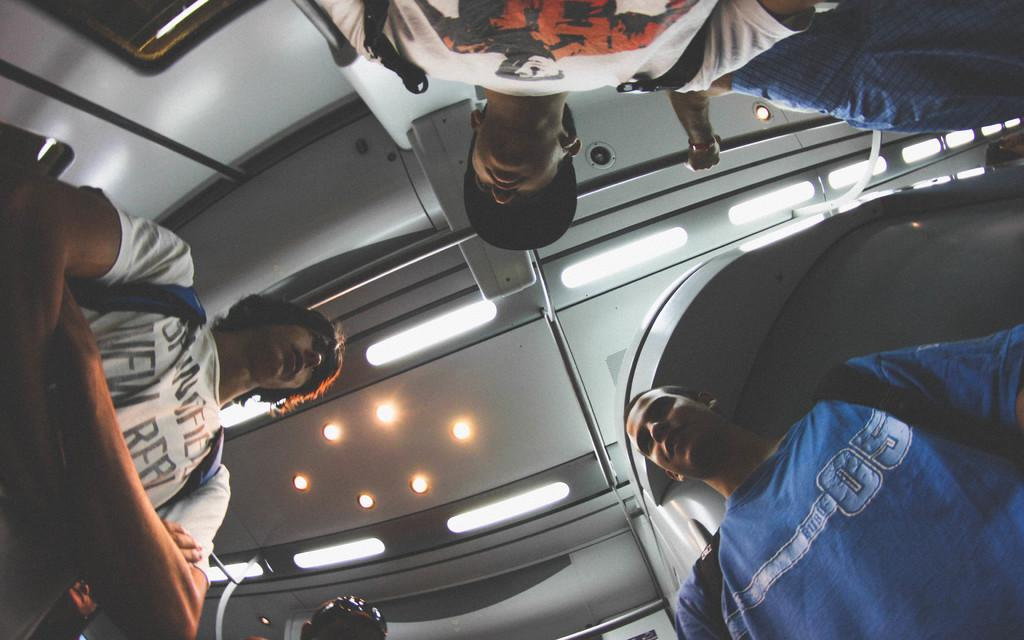How many people are in the image? There are people in the image, but the exact number is not specified. What are some of the people wearing in the image? Three of the people are wearing backpacks. What can be seen illuminated in the image? There are lights in the image. What type of structure is present in the image? There is a wall in the image. What type of cup is being used by the jellyfish in the image? There are no jellyfish or cups present in the image. 